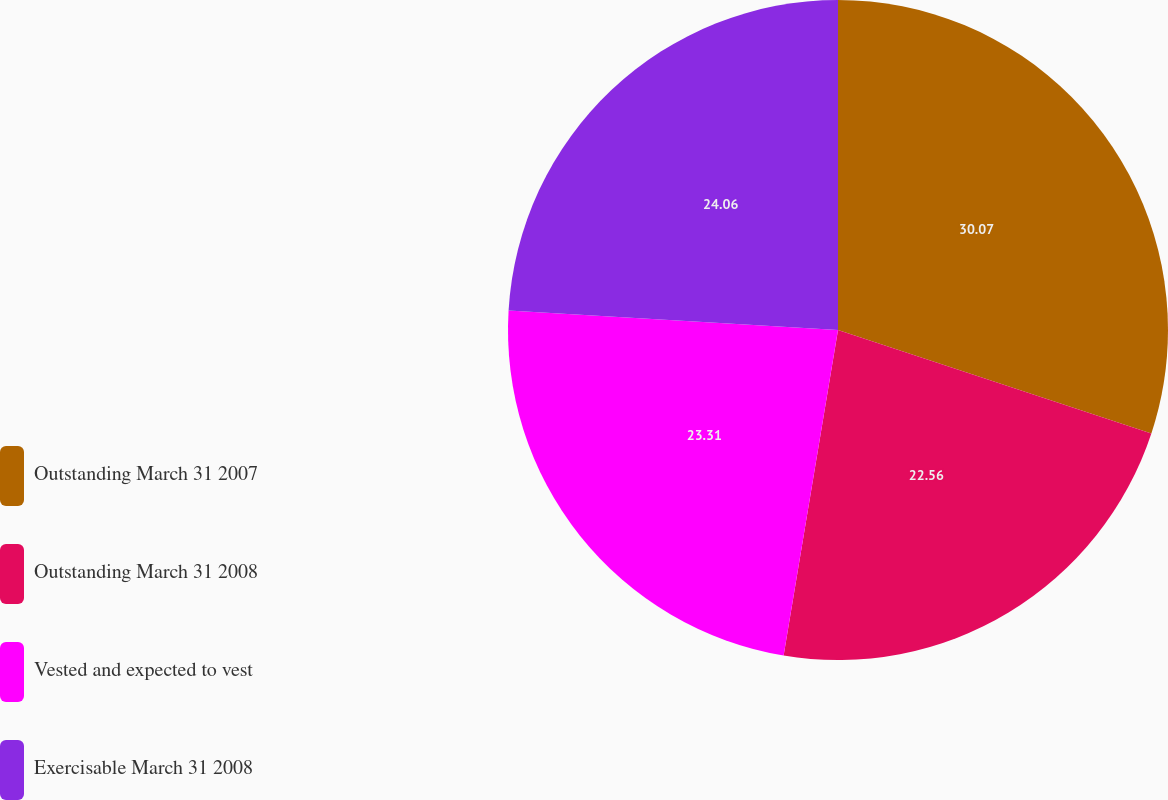Convert chart to OTSL. <chart><loc_0><loc_0><loc_500><loc_500><pie_chart><fcel>Outstanding March 31 2007<fcel>Outstanding March 31 2008<fcel>Vested and expected to vest<fcel>Exercisable March 31 2008<nl><fcel>30.08%<fcel>22.56%<fcel>23.31%<fcel>24.06%<nl></chart> 